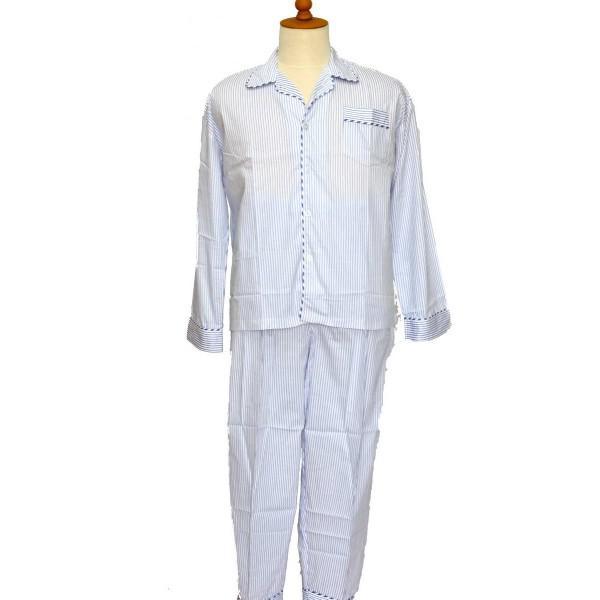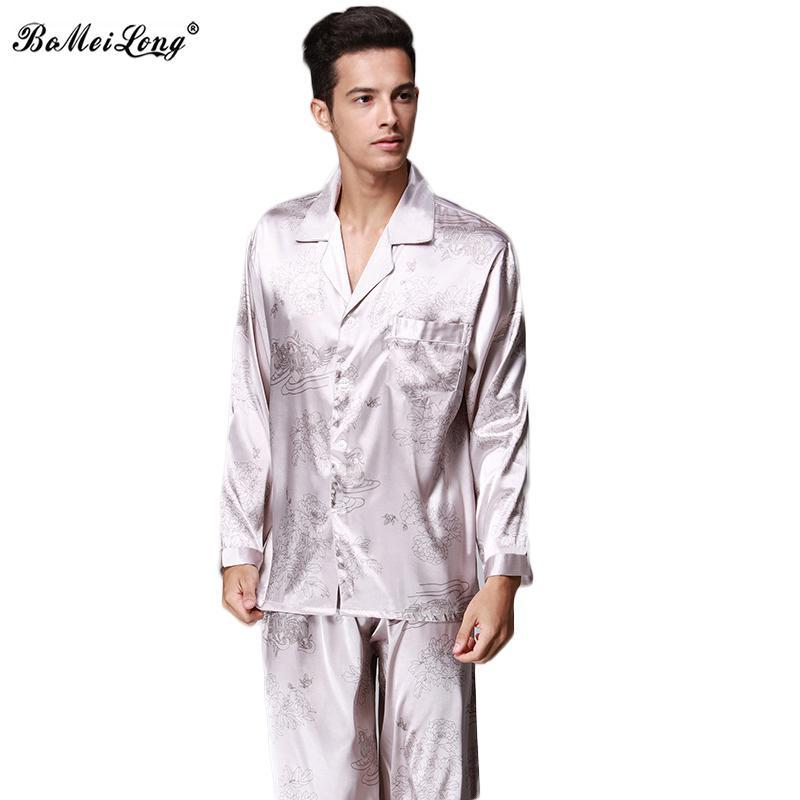The first image is the image on the left, the second image is the image on the right. Analyze the images presented: Is the assertion "the mans feet can be seen in the right pic" valid? Answer yes or no. No. 